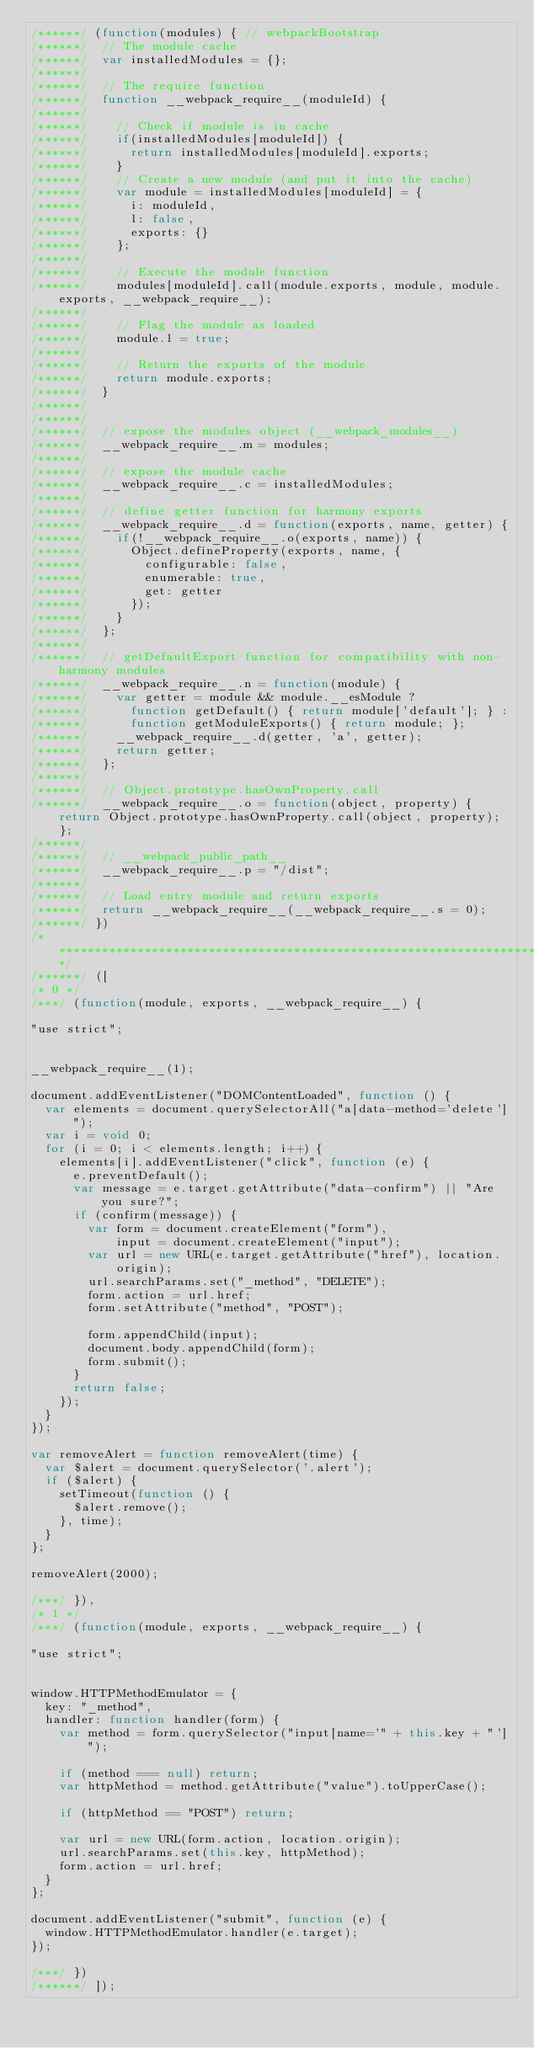<code> <loc_0><loc_0><loc_500><loc_500><_JavaScript_>/******/ (function(modules) { // webpackBootstrap
/******/ 	// The module cache
/******/ 	var installedModules = {};
/******/
/******/ 	// The require function
/******/ 	function __webpack_require__(moduleId) {
/******/
/******/ 		// Check if module is in cache
/******/ 		if(installedModules[moduleId]) {
/******/ 			return installedModules[moduleId].exports;
/******/ 		}
/******/ 		// Create a new module (and put it into the cache)
/******/ 		var module = installedModules[moduleId] = {
/******/ 			i: moduleId,
/******/ 			l: false,
/******/ 			exports: {}
/******/ 		};
/******/
/******/ 		// Execute the module function
/******/ 		modules[moduleId].call(module.exports, module, module.exports, __webpack_require__);
/******/
/******/ 		// Flag the module as loaded
/******/ 		module.l = true;
/******/
/******/ 		// Return the exports of the module
/******/ 		return module.exports;
/******/ 	}
/******/
/******/
/******/ 	// expose the modules object (__webpack_modules__)
/******/ 	__webpack_require__.m = modules;
/******/
/******/ 	// expose the module cache
/******/ 	__webpack_require__.c = installedModules;
/******/
/******/ 	// define getter function for harmony exports
/******/ 	__webpack_require__.d = function(exports, name, getter) {
/******/ 		if(!__webpack_require__.o(exports, name)) {
/******/ 			Object.defineProperty(exports, name, {
/******/ 				configurable: false,
/******/ 				enumerable: true,
/******/ 				get: getter
/******/ 			});
/******/ 		}
/******/ 	};
/******/
/******/ 	// getDefaultExport function for compatibility with non-harmony modules
/******/ 	__webpack_require__.n = function(module) {
/******/ 		var getter = module && module.__esModule ?
/******/ 			function getDefault() { return module['default']; } :
/******/ 			function getModuleExports() { return module; };
/******/ 		__webpack_require__.d(getter, 'a', getter);
/******/ 		return getter;
/******/ 	};
/******/
/******/ 	// Object.prototype.hasOwnProperty.call
/******/ 	__webpack_require__.o = function(object, property) { return Object.prototype.hasOwnProperty.call(object, property); };
/******/
/******/ 	// __webpack_public_path__
/******/ 	__webpack_require__.p = "/dist";
/******/
/******/ 	// Load entry module and return exports
/******/ 	return __webpack_require__(__webpack_require__.s = 0);
/******/ })
/************************************************************************/
/******/ ([
/* 0 */
/***/ (function(module, exports, __webpack_require__) {

"use strict";


__webpack_require__(1);

document.addEventListener("DOMContentLoaded", function () {
  var elements = document.querySelectorAll("a[data-method='delete']");
  var i = void 0;
  for (i = 0; i < elements.length; i++) {
    elements[i].addEventListener("click", function (e) {
      e.preventDefault();
      var message = e.target.getAttribute("data-confirm") || "Are you sure?";
      if (confirm(message)) {
        var form = document.createElement("form"),
            input = document.createElement("input");
        var url = new URL(e.target.getAttribute("href"), location.origin);
        url.searchParams.set("_method", "DELETE");
        form.action = url.href;
        form.setAttribute("method", "POST");

        form.appendChild(input);
        document.body.appendChild(form);
        form.submit();
      }
      return false;
    });
  }
});

var removeAlert = function removeAlert(time) {
  var $alert = document.querySelector('.alert');
  if ($alert) {
    setTimeout(function () {
      $alert.remove();
    }, time);
  }
};

removeAlert(2000);

/***/ }),
/* 1 */
/***/ (function(module, exports, __webpack_require__) {

"use strict";


window.HTTPMethodEmulator = {
  key: "_method",
  handler: function handler(form) {
    var method = form.querySelector("input[name='" + this.key + "']");

    if (method === null) return;
    var httpMethod = method.getAttribute("value").toUpperCase();

    if (httpMethod == "POST") return;

    var url = new URL(form.action, location.origin);
    url.searchParams.set(this.key, httpMethod);
    form.action = url.href;
  }
};

document.addEventListener("submit", function (e) {
  window.HTTPMethodEmulator.handler(e.target);
});

/***/ })
/******/ ]);</code> 